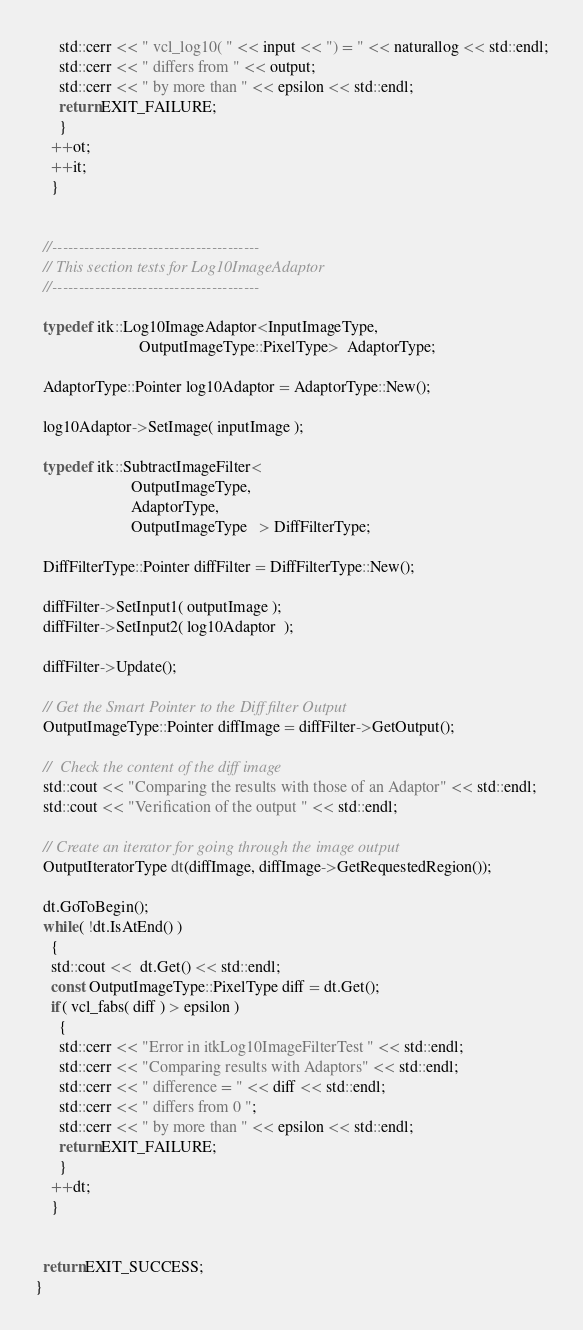Convert code to text. <code><loc_0><loc_0><loc_500><loc_500><_C++_>      std::cerr << " vcl_log10( " << input << ") = " << naturallog << std::endl;
      std::cerr << " differs from " << output;
      std::cerr << " by more than " << epsilon << std::endl;
      return EXIT_FAILURE;
      }
    ++ot;
    ++it;
    }


  //---------------------------------------
  // This section tests for Log10ImageAdaptor
  //---------------------------------------

  typedef itk::Log10ImageAdaptor<InputImageType,
                          OutputImageType::PixelType>  AdaptorType;

  AdaptorType::Pointer log10Adaptor = AdaptorType::New();

  log10Adaptor->SetImage( inputImage );

  typedef itk::SubtractImageFilter<
                        OutputImageType,
                        AdaptorType,
                        OutputImageType   > DiffFilterType;

  DiffFilterType::Pointer diffFilter = DiffFilterType::New();

  diffFilter->SetInput1( outputImage );
  diffFilter->SetInput2( log10Adaptor  );

  diffFilter->Update();

  // Get the Smart Pointer to the Diff filter Output
  OutputImageType::Pointer diffImage = diffFilter->GetOutput();

  //  Check the content of the diff image
  std::cout << "Comparing the results with those of an Adaptor" << std::endl;
  std::cout << "Verification of the output " << std::endl;

  // Create an iterator for going through the image output
  OutputIteratorType dt(diffImage, diffImage->GetRequestedRegion());

  dt.GoToBegin();
  while( !dt.IsAtEnd() )
    {
    std::cout <<  dt.Get() << std::endl;
    const OutputImageType::PixelType diff = dt.Get();
    if( vcl_fabs( diff ) > epsilon )
      {
      std::cerr << "Error in itkLog10ImageFilterTest " << std::endl;
      std::cerr << "Comparing results with Adaptors" << std::endl;
      std::cerr << " difference = " << diff << std::endl;
      std::cerr << " differs from 0 ";
      std::cerr << " by more than " << epsilon << std::endl;
      return EXIT_FAILURE;
      }
    ++dt;
    }


  return EXIT_SUCCESS;
}
</code> 